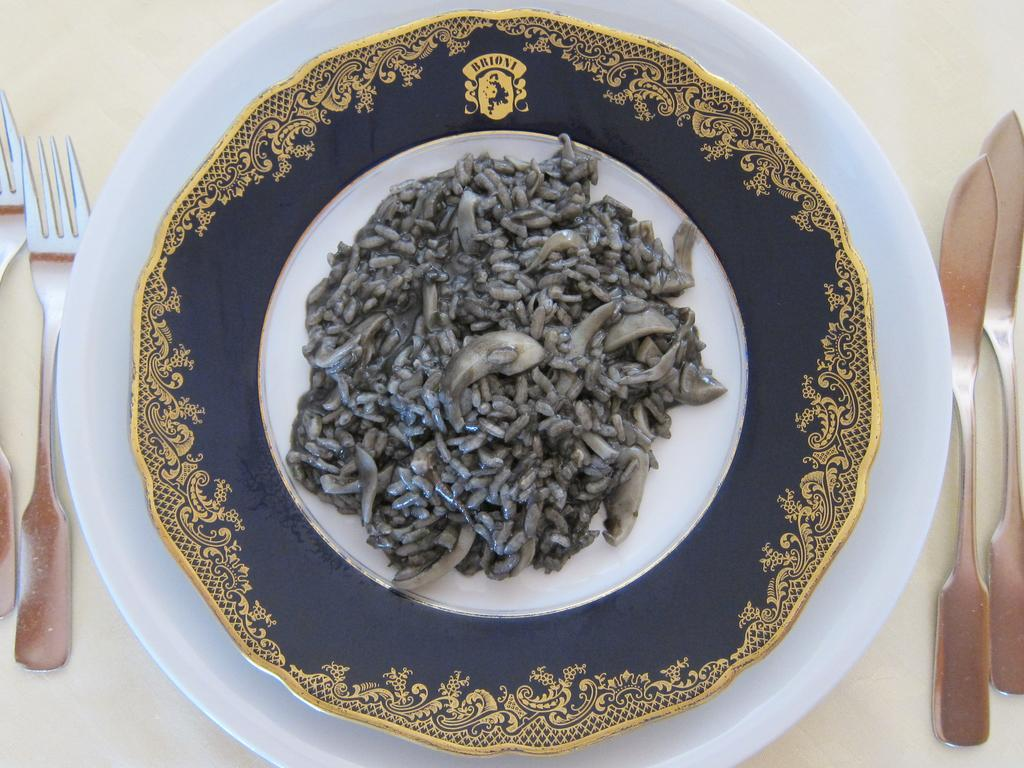What objects are used for serving or eating food in the image? There are plates, knives, and forks visible in the image. What type of food can be seen in the image? There is food in the image, but the specific type is not mentioned. What color is the platform on which the objects are placed? The platform is white. Can you tell me how many people are playing in the park in the image? There is no park or people playing in the image; it features plates, knives, forks, food, and a white platform. What type of liquid is being poured into the glass in the image? There is no glass or liquid present in the image. 